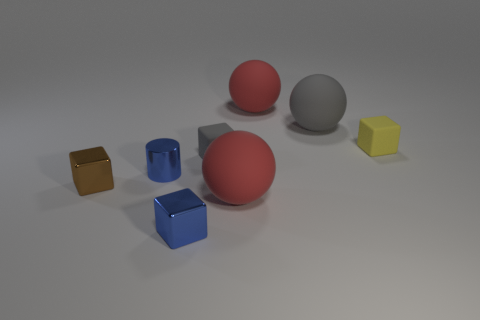What color is the other metallic thing that is the same shape as the small brown metal object? blue 